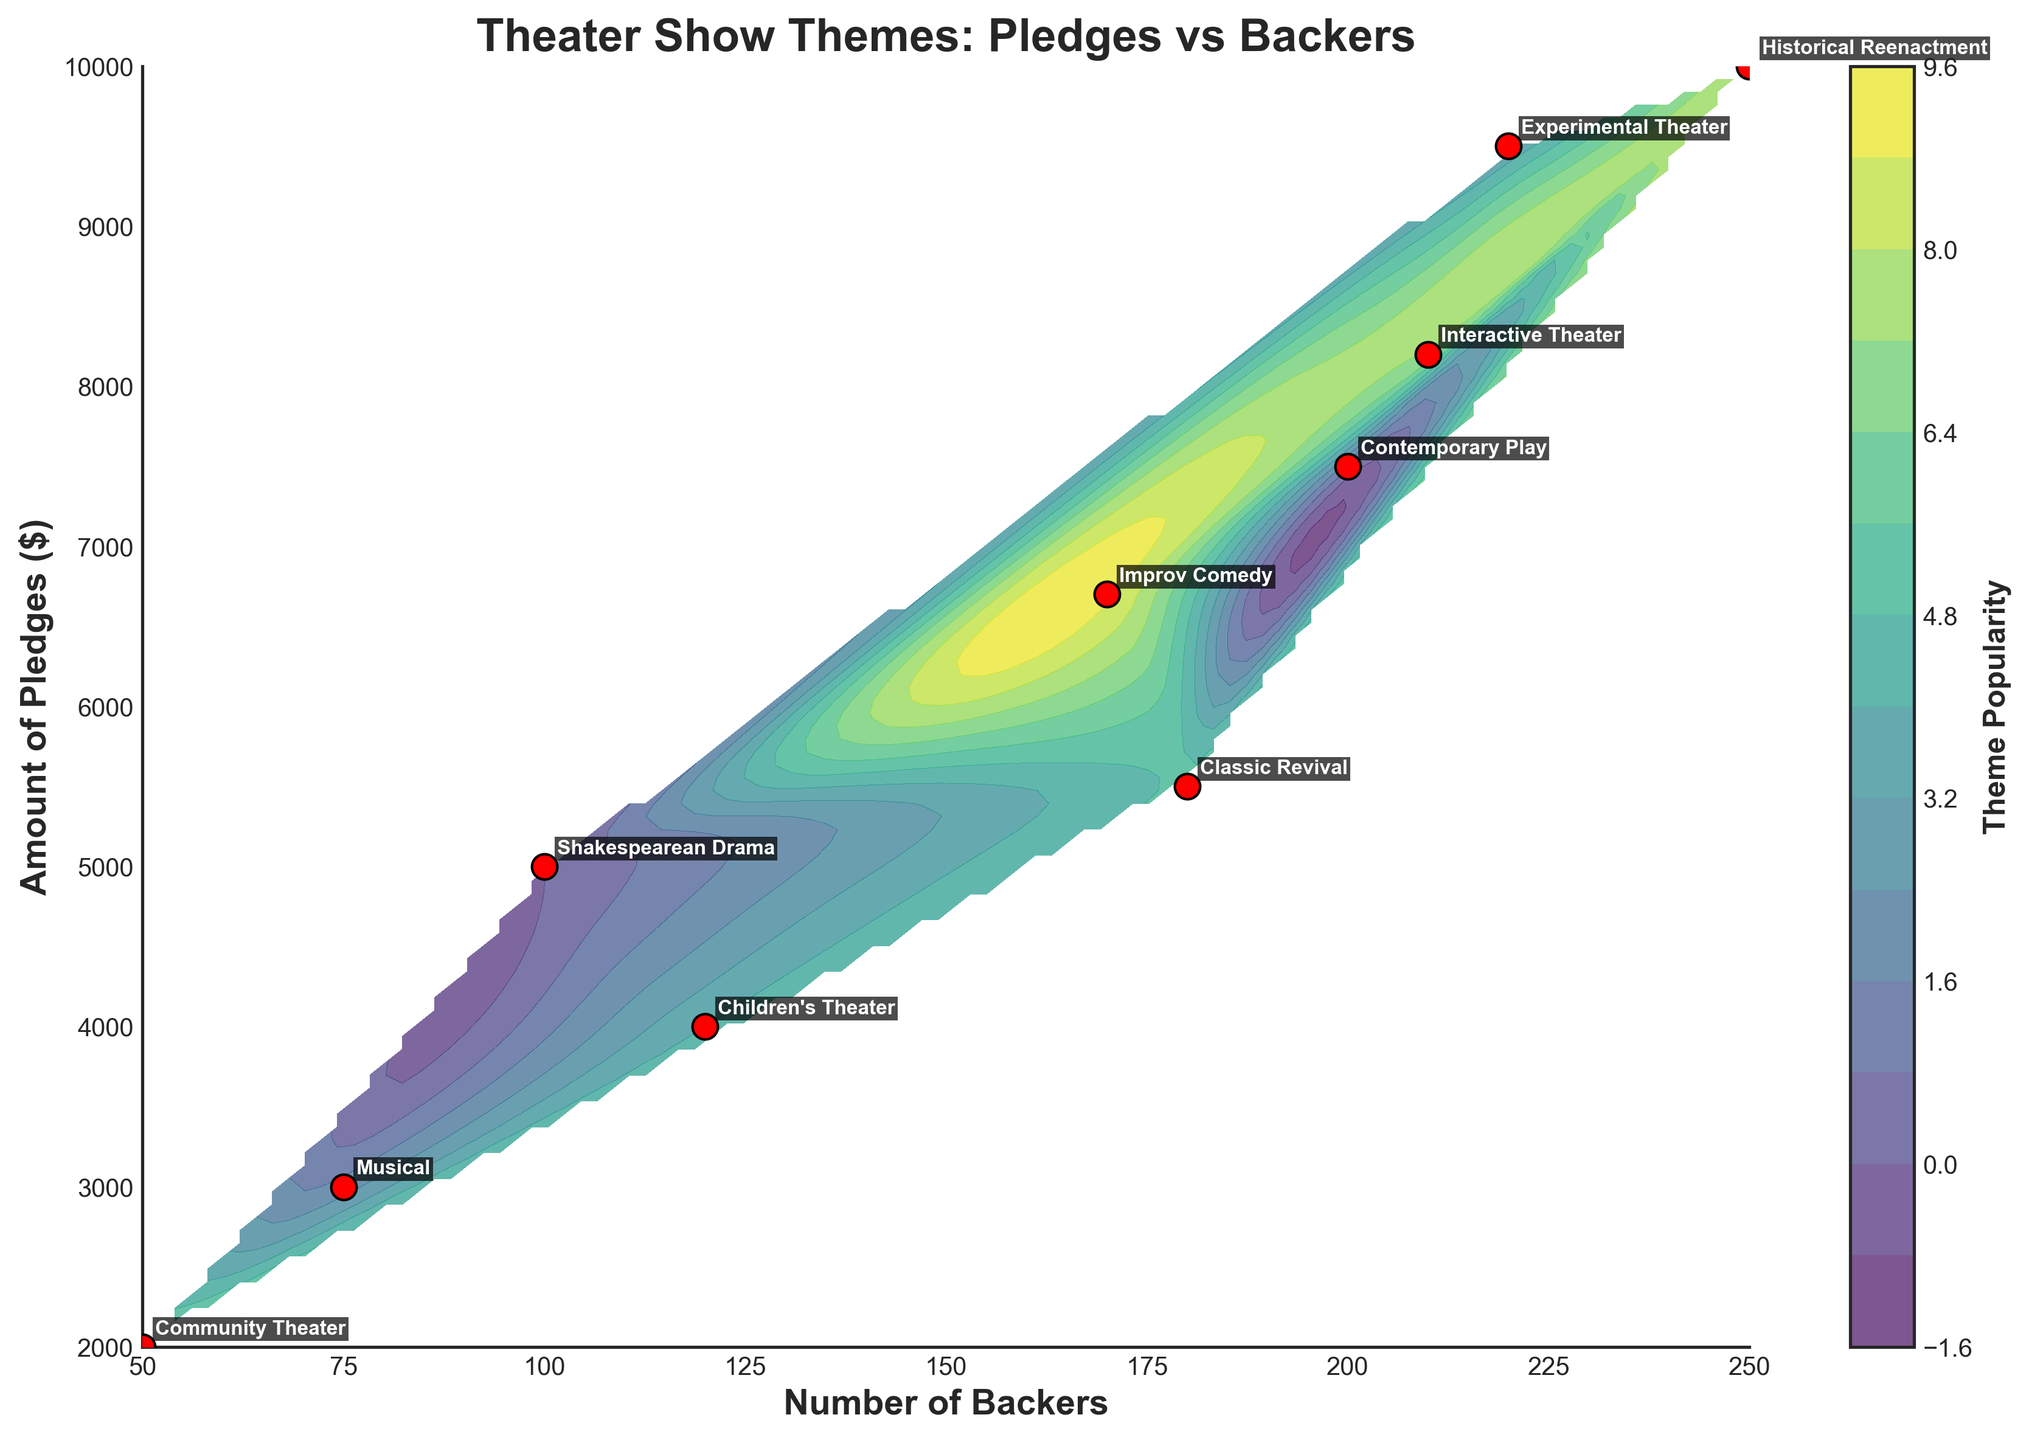What is the title of the plot? The title is displayed at the top of the figure. It is labeled as 'Theater Show Themes: Pledges vs Backers'.
Answer: Theater Show Themes: Pledges vs Backers What are the axis labels? The X-axis is labeled as 'Number of Backers', and the Y-axis is labeled as 'Amount of Pledges ($)'.
Answer: Number of Backers and Amount of Pledges ($) Which theater show theme has the highest amount of pledges? By looking at the figure, we can see that 'Historical Reenactment' has the highest value on the Y-axis for 'Amount of Pledges'.
Answer: Historical Reenactment How many theater show themes are plotted in the figure? Counting the labels of the theater show themes on the plot reveals that there are 10 different themes.
Answer: 10 Which theater show theme has the lowest number of backers? By looking at the figure, we see that 'Community Theater' has the lowest value on the X-axis for 'Number of Backers'.
Answer: Community Theater What is the contour color map used in the plot? The color map used in the contour is a gradient from the 'viridis' color scheme.
Answer: viridis What does the color bar represent in the figure? The color bar on the side of the plot is labeled 'Theme Popularity', which represents the interpolated popularity of the themes.
Answer: Theme Popularity If you double the number of backers for 'Musical', how does its position change on the plot? 'Musical' has 75 backers. Doubling this gives 150 backers, placing it near the middle-right of the plot, but the Y-axis 'Amount of Pledges' remains the same, so it moves horizontally to around the 'Amount of Pledges' value.
Answer: Moves horizontally to (~75, 3000) Which theater show theme is closest to the intersection of 200 backers and $8000 pledges? By examining the plot, ‘Interactive Theater’ is closest to the intersection of 200 backers and $8000 pledges.
Answer: Interactive Theater How does the 'Children's Theater' theme compare to the 'Classic Revival' theme in terms of backers and pledges? 'Children's Theater' has fewer backers and pledges than 'Classic Revival'. 'Children's Theater' has 120 backers and $4000 pledges, while 'Classic Revival' has 180 backers and $5500 pledges.
Answer: Fewer backers and pledges 